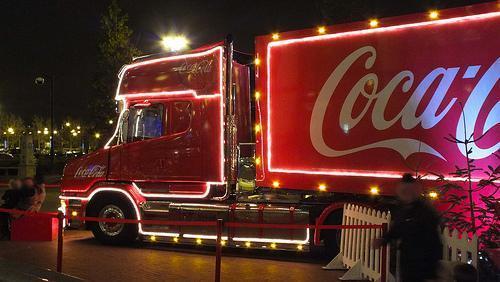How many trucks are there?
Give a very brief answer. 1. 